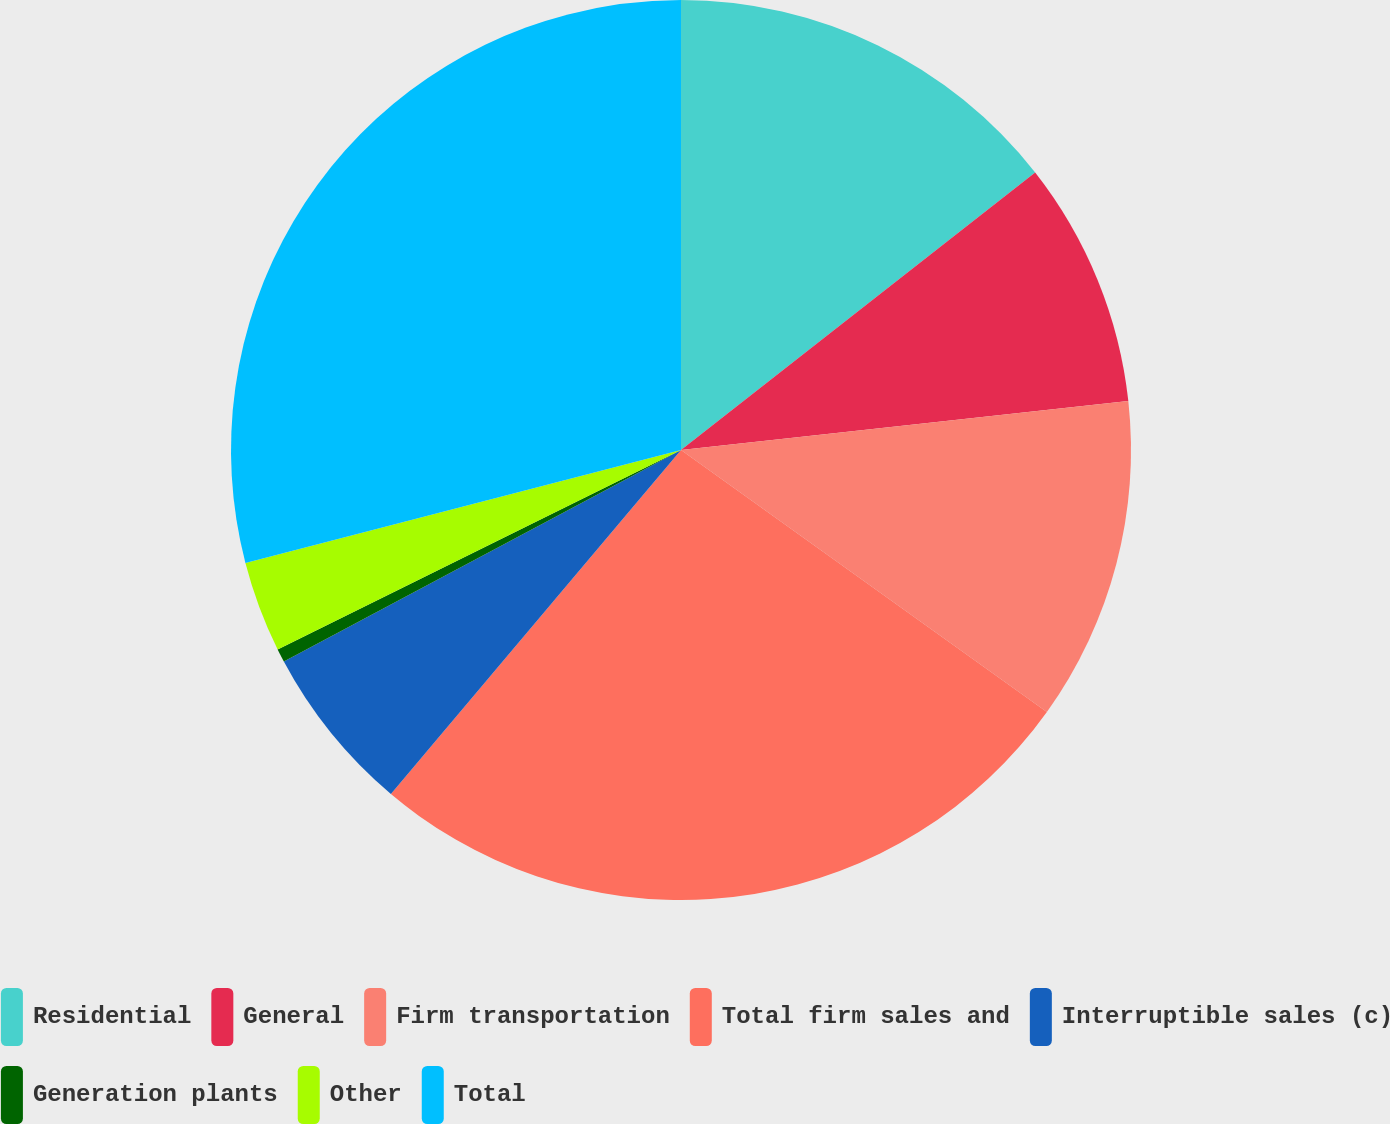Convert chart. <chart><loc_0><loc_0><loc_500><loc_500><pie_chart><fcel>Residential<fcel>General<fcel>Firm transportation<fcel>Total firm sales and<fcel>Interruptible sales (c)<fcel>Generation plants<fcel>Other<fcel>Total<nl><fcel>14.42%<fcel>8.84%<fcel>11.63%<fcel>26.26%<fcel>6.06%<fcel>0.48%<fcel>3.27%<fcel>29.04%<nl></chart> 